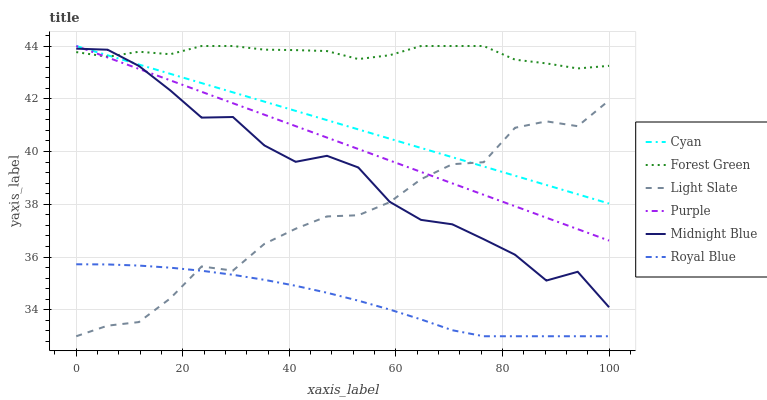Does Royal Blue have the minimum area under the curve?
Answer yes or no. Yes. Does Forest Green have the maximum area under the curve?
Answer yes or no. Yes. Does Light Slate have the minimum area under the curve?
Answer yes or no. No. Does Light Slate have the maximum area under the curve?
Answer yes or no. No. Is Purple the smoothest?
Answer yes or no. Yes. Is Midnight Blue the roughest?
Answer yes or no. Yes. Is Royal Blue the smoothest?
Answer yes or no. No. Is Royal Blue the roughest?
Answer yes or no. No. Does Royal Blue have the lowest value?
Answer yes or no. Yes. Does Purple have the lowest value?
Answer yes or no. No. Does Cyan have the highest value?
Answer yes or no. Yes. Does Light Slate have the highest value?
Answer yes or no. No. Is Royal Blue less than Cyan?
Answer yes or no. Yes. Is Midnight Blue greater than Royal Blue?
Answer yes or no. Yes. Does Purple intersect Light Slate?
Answer yes or no. Yes. Is Purple less than Light Slate?
Answer yes or no. No. Is Purple greater than Light Slate?
Answer yes or no. No. Does Royal Blue intersect Cyan?
Answer yes or no. No. 